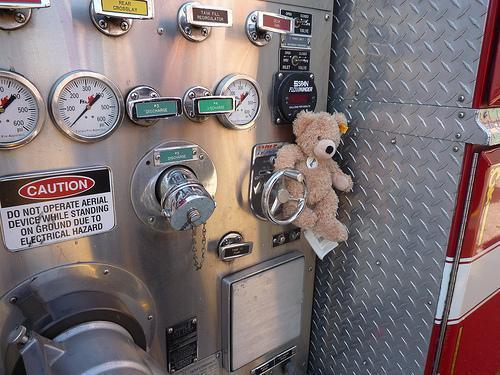How many teddy bears are there?
Give a very brief answer. 1. 